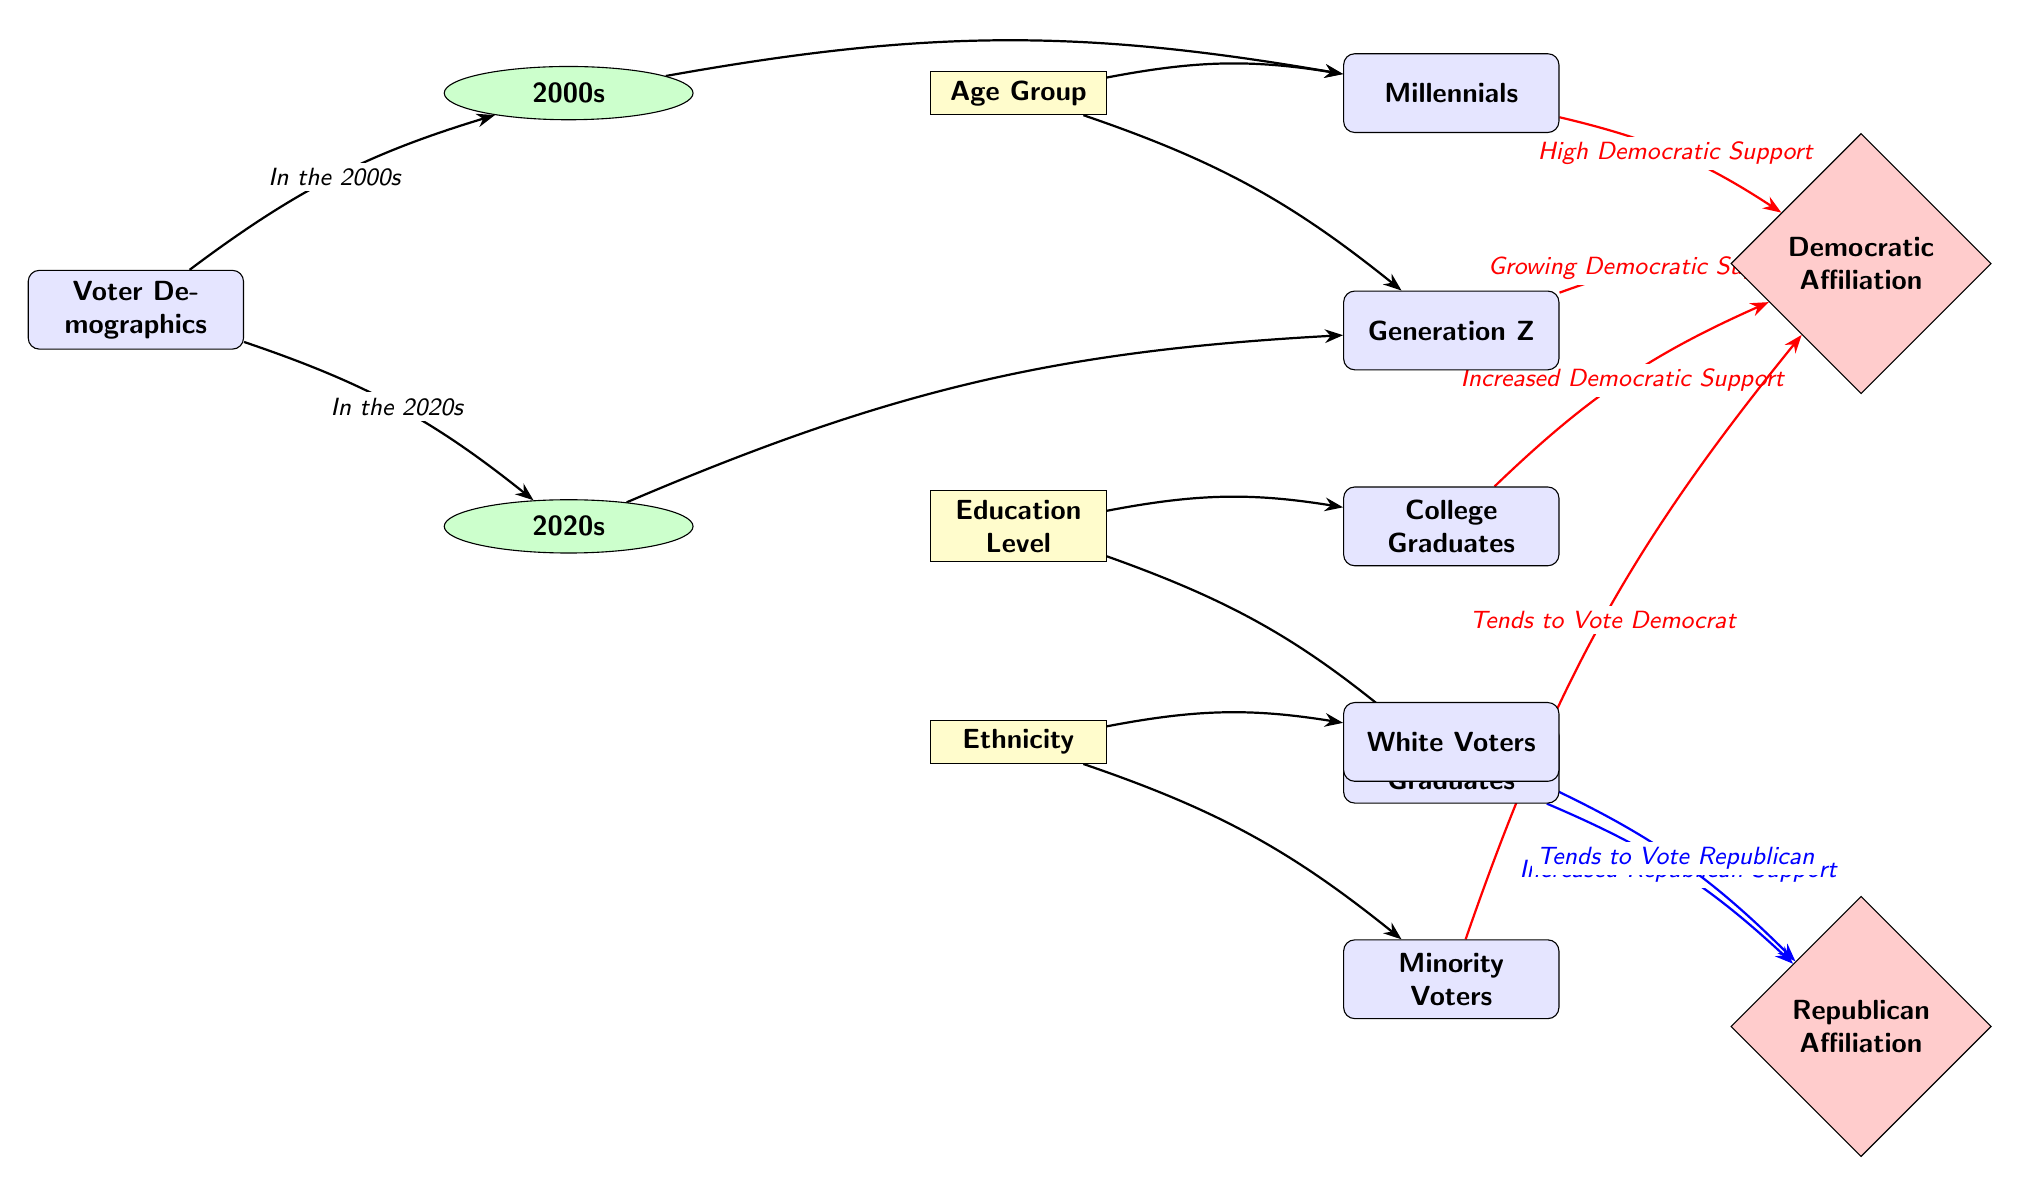What category is associated with the minority voters? The diagram indicates that the minority voters are associated with the ethnicity category since they are placed directly below it and connected by an arrow pointing to "Minority Voters."
Answer: Ethnicity Which two age groups are represented in the diagram? The diagram contains two nodes that represent age groups: Millennials and Generation Z, each linked to their respective categories as part of the voter demographics.
Answer: Millennials and Generation Z What type of affiliation do college graduates show according to the diagram? The diagram shows that college graduates have an increased Democratic support, which is illustrated by the red arrow pointing from the college node to the Democratic Affiliation node.
Answer: Increased Democratic Support How do non-college graduates align in terms of political affiliation? The diagram indicates that non-college graduates tend to show increased Republican support, as represented by the arrow pointing to the Republican Affiliation node marked in blue.
Answer: Increased Republican Support What demographic is likely to vote Republican based on the diagram? The diagram highlights that White Voters tend to vote Republican, as indicated by the blue arrow leading to the Republican Affiliation node.
Answer: White Voters Which era shows a growing Democratic support trend? The diagram indicates that the 2020s era has a growing Democratic support trend, as illustrated by the arrow linking Generation Z to the Democratic Affiliation, implying a trend change from the previous era.
Answer: 2020s How many total voter demographic categories are there in the diagram? The diagram shows three categories: Age Group, Education Level, and Ethnicity, which are the main categories branching from the Voter Demographics node.
Answer: Three What is the general trend of Democratic support between the two eras? By comparing the connections from the 2000s and the 2020s, the diagram shows a significant increase in Democratic support from the Millennials in the 2000s to the Generation Z in the 2020s, thus highlighting a positive trend toward Democratic affiliation.
Answer: Increase in Democratic Support 